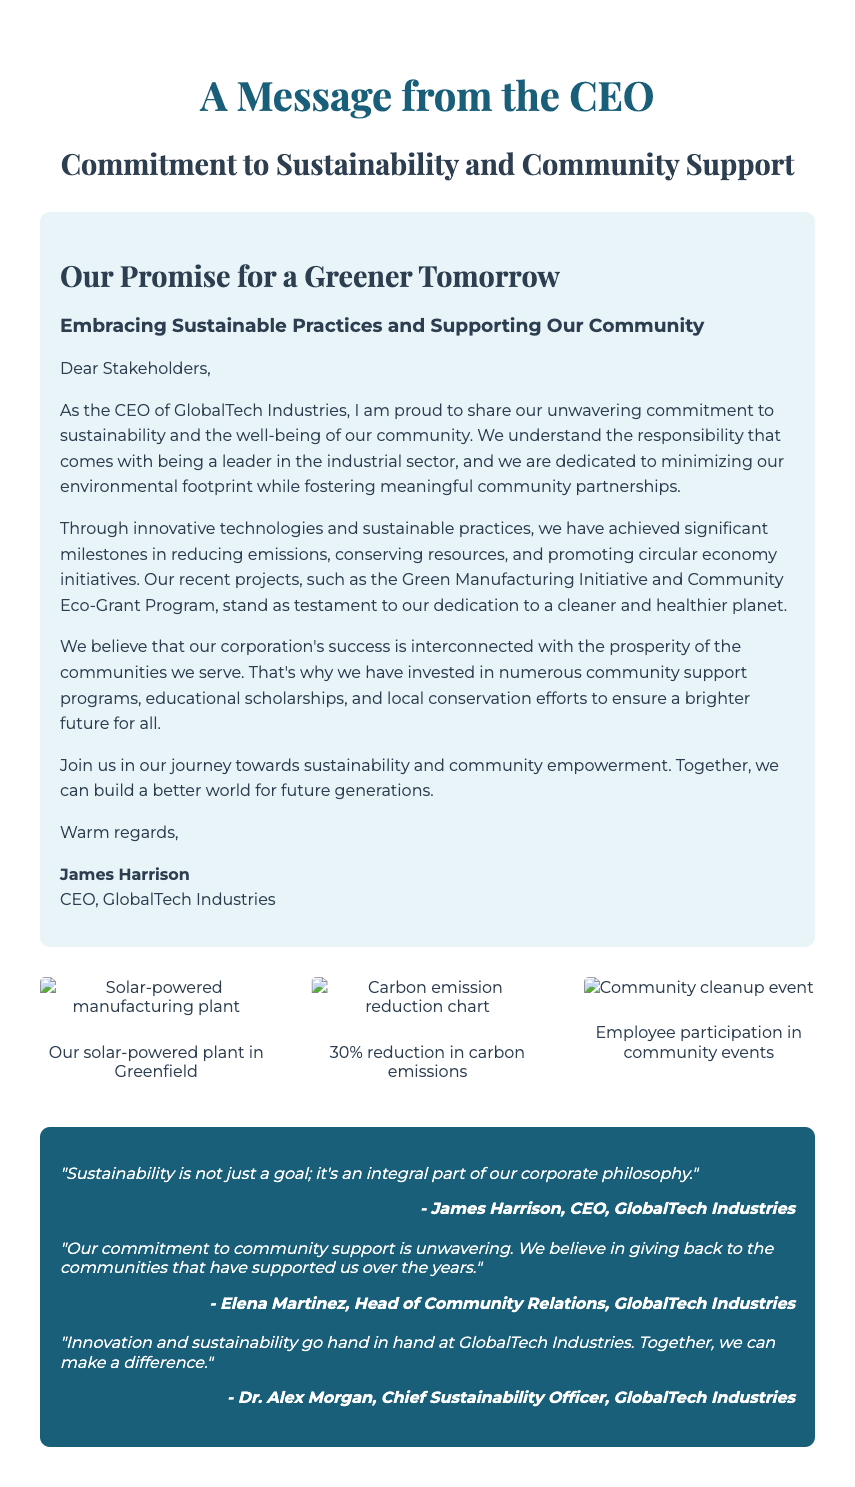what is the name of the CEO? The CEO's name is mentioned at the end of the message in the document.
Answer: James Harrison what is the title of the message from the CEO? The document prominently features the title provided in the header.
Answer: A Message from the CEO what is the main initiative mentioned for reducing emissions? The document stands out the specific initiative focused on emissions reduction.
Answer: Green Manufacturing Initiative what percentage of carbon emissions has been reduced? The document specifies the amount of reduction in emissions highlighted in a visual.
Answer: 30% who is the Head of Community Relations? The document includes a quote from a specific person identified in the text.
Answer: Elena Martinez what concept is described as an integral part of the corporate philosophy? The document quotes the CEO on an important principle of the corporation.
Answer: Sustainability what type of event is depicted in the community photo? The document provides a description of the visual showing community engagement.
Answer: Community cleanup event how does the CEO describe the company's commitment to community support? The document highlights the specific sentiment expressed by the Head of Community Relations.
Answer: Unwavering what image is shown of the corporation's solar initiatives? The document references an image depicting this specific aspect of the corporation's efforts.
Answer: Solar-powered plant in Greenfield what is the purpose of the Community Eco-Grant Program? The message discusses the nature of this program and its relevance in supporting communities.
Answer: Community support 